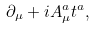Convert formula to latex. <formula><loc_0><loc_0><loc_500><loc_500>\partial _ { \mu } + i A ^ { a } _ { \mu } t ^ { a } ,</formula> 